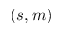Convert formula to latex. <formula><loc_0><loc_0><loc_500><loc_500>( s , m )</formula> 